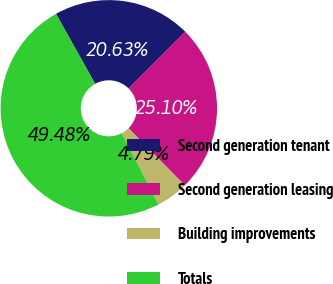<chart> <loc_0><loc_0><loc_500><loc_500><pie_chart><fcel>Second generation tenant<fcel>Second generation leasing<fcel>Building improvements<fcel>Totals<nl><fcel>20.63%<fcel>25.1%<fcel>4.79%<fcel>49.48%<nl></chart> 